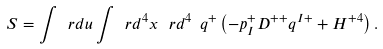Convert formula to latex. <formula><loc_0><loc_0><loc_500><loc_500>S = \int \ r d u \int \ r d ^ { 4 } x \, \ r d ^ { 4 } \ q ^ { + } \left ( - p _ { I } ^ { + } D ^ { + + } q ^ { I + } + H ^ { + 4 } \right ) .</formula> 